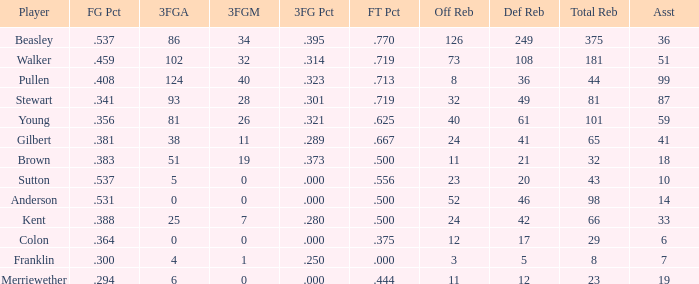What is the total number of offensive rebounds for players with under 65 total rebounds, 5 defensive rebounds, and under 7 assists? 0.0. 